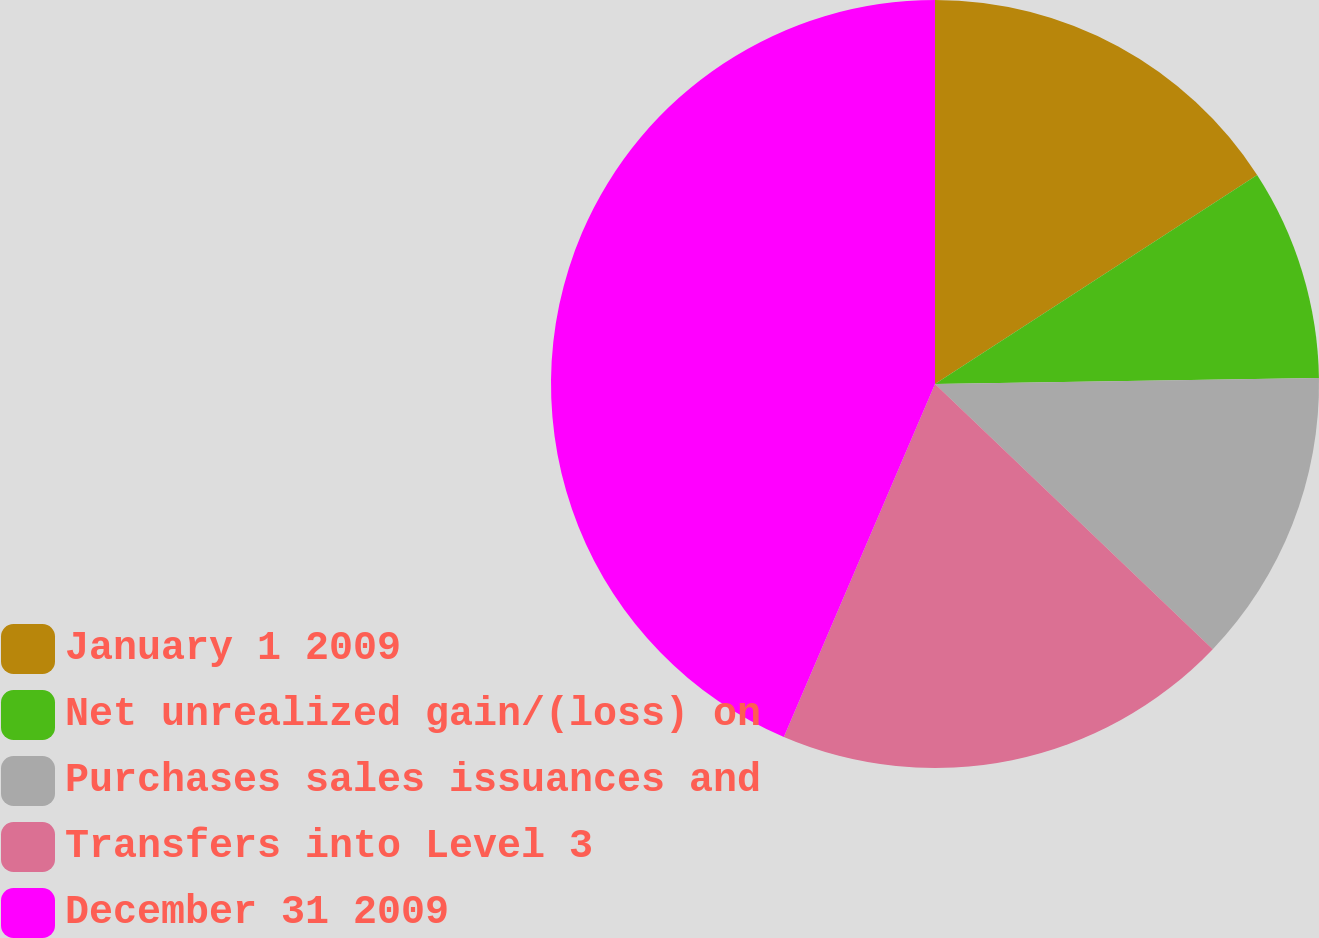<chart> <loc_0><loc_0><loc_500><loc_500><pie_chart><fcel>January 1 2009<fcel>Net unrealized gain/(loss) on<fcel>Purchases sales issuances and<fcel>Transfers into Level 3<fcel>December 31 2009<nl><fcel>15.84%<fcel>8.91%<fcel>12.38%<fcel>19.31%<fcel>43.56%<nl></chart> 